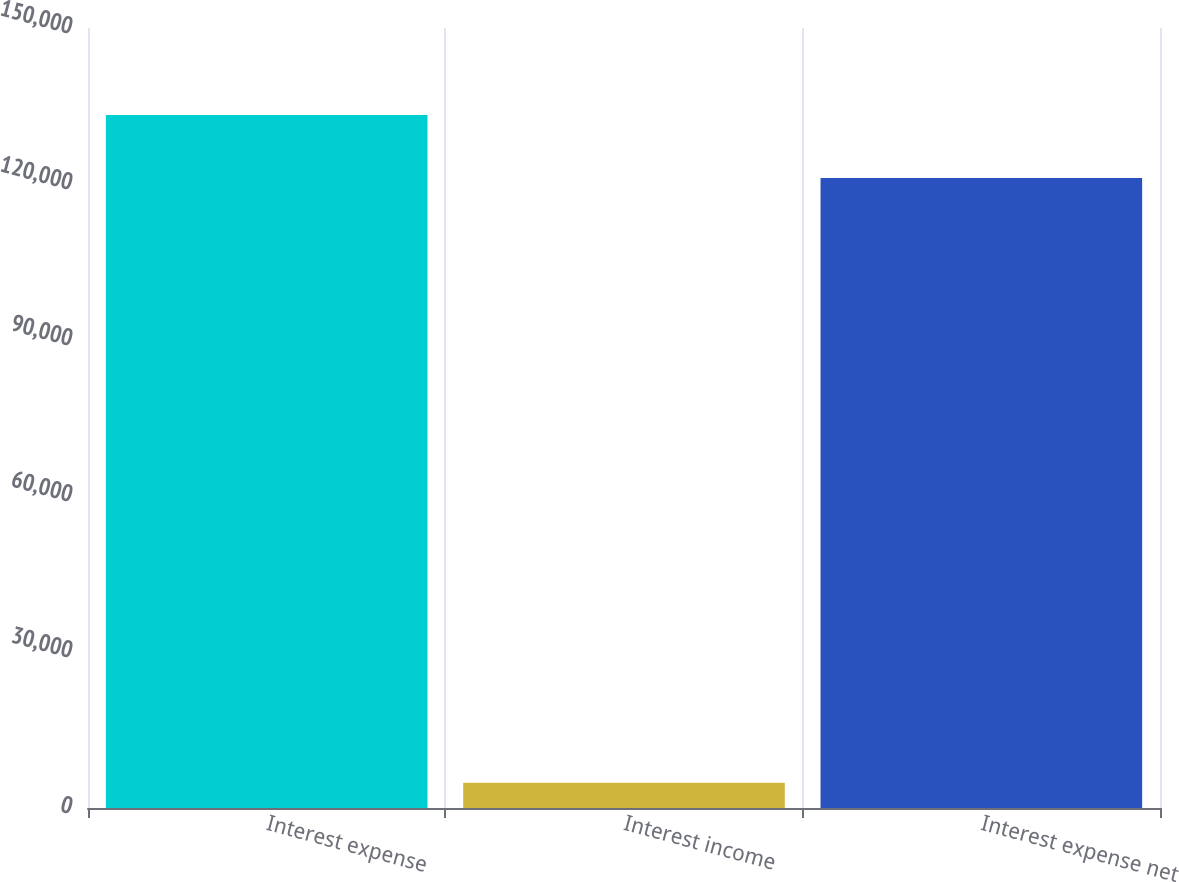Convert chart. <chart><loc_0><loc_0><loc_500><loc_500><bar_chart><fcel>Interest expense<fcel>Interest income<fcel>Interest expense net<nl><fcel>133255<fcel>4854<fcel>121141<nl></chart> 